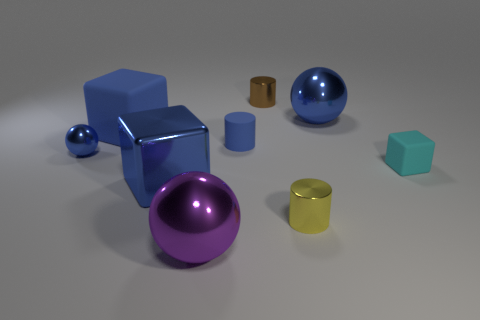Subtract all tiny blue metallic balls. How many balls are left? 2 Subtract all cylinders. How many objects are left? 6 Subtract all large green cylinders. Subtract all small yellow things. How many objects are left? 8 Add 8 yellow shiny objects. How many yellow shiny objects are left? 9 Add 7 large blue rubber objects. How many large blue rubber objects exist? 8 Subtract 1 yellow cylinders. How many objects are left? 8 